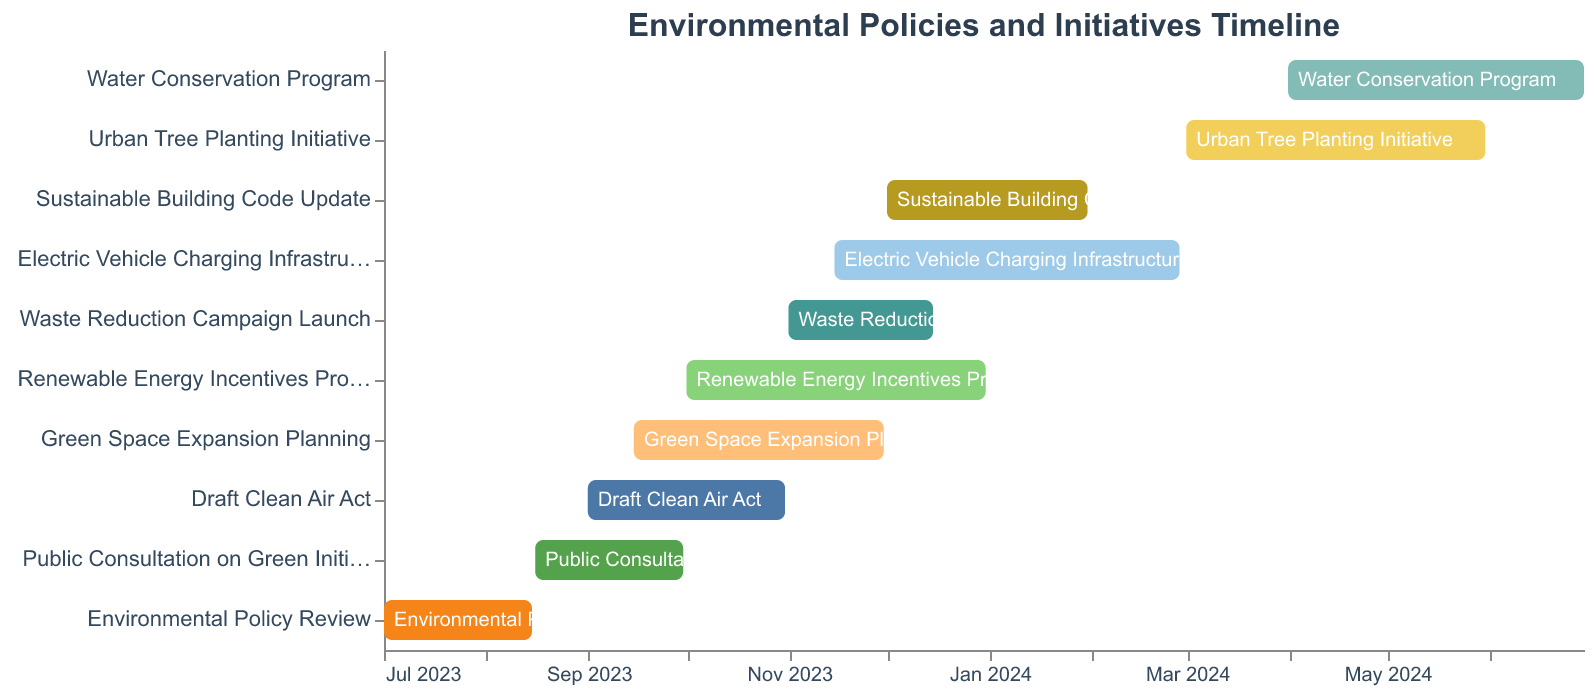What is the title of the chart? The title can be found at the top of the chart. It is written in a larger font size and different color to stand out.
Answer: Environmental Policies and Initiatives Timeline Which task started first? The chart uses a temporal axis to show the start dates of tasks. The first bar from the bottom corresponds to the earliest starting task.
Answer: Environmental Policy Review Which task has the longest duration? By examining the length of the bars, the longest bar indicates the task with the longest duration.
Answer: Electric Vehicle Charging Infrastructure How many tasks are continuing into 2024? To find this, look for tasks whose bars extend past December 2023 on the temporal axis.
Answer: 4 Which tasks are overlapping in September 2023? Observe the bars that span through September 2023 to determine which tasks overlap during this period.
Answer: Public Consultation on Green Initiatives, Draft Clean Air Act, Green Space Expansion Planning What is the expected completion date of the Green Space Expansion Planning? The completion date can be found at the end of the bar for the Green Space Expansion Planning task.
Answer: November 30, 2023 How many tasks start in November 2023? Count the number of bars that begin in November 2023 based on the temporal axis.
Answer: 2 Which task is scheduled to end last? Locate the furthest right end point of any task bar on the temporal axis to identify the last ending task.
Answer: Water Conservation Program What is the duration of the Sustainable Building Code Update? To find the duration, calculate the difference between the start and end dates for the Sustainable Building Code Update.
Answer: 2 months Which task ends at the same time the Water Conservation Program starts? Find the end date of any task that matches the start date of the Water Conservation Program on the temporal axis.
Answer: Urban Tree Planting Initiative 